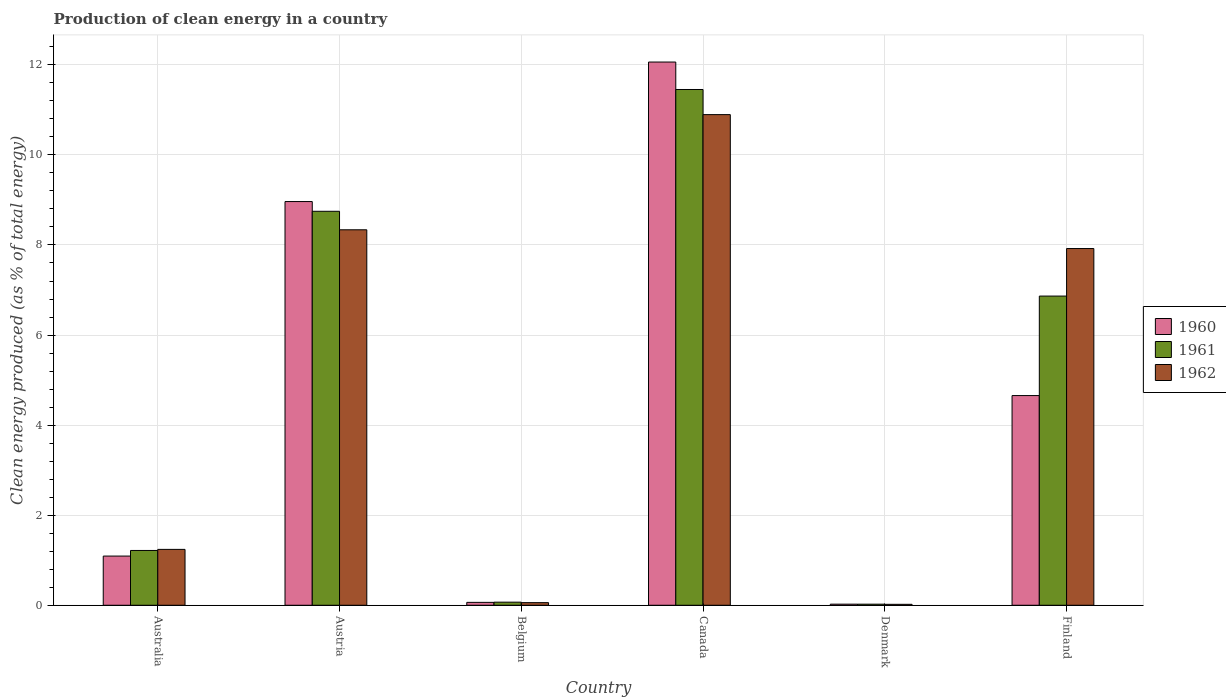How many different coloured bars are there?
Provide a succinct answer. 3. What is the percentage of clean energy produced in 1960 in Australia?
Give a very brief answer. 1.09. Across all countries, what is the maximum percentage of clean energy produced in 1960?
Ensure brevity in your answer.  12.06. Across all countries, what is the minimum percentage of clean energy produced in 1961?
Offer a terse response. 0.02. What is the total percentage of clean energy produced in 1961 in the graph?
Provide a short and direct response. 28.38. What is the difference between the percentage of clean energy produced in 1961 in Austria and that in Denmark?
Give a very brief answer. 8.72. What is the difference between the percentage of clean energy produced in 1960 in Belgium and the percentage of clean energy produced in 1961 in Canada?
Make the answer very short. -11.39. What is the average percentage of clean energy produced in 1960 per country?
Make the answer very short. 4.48. What is the difference between the percentage of clean energy produced of/in 1962 and percentage of clean energy produced of/in 1960 in Belgium?
Your answer should be compact. -0.01. What is the ratio of the percentage of clean energy produced in 1962 in Australia to that in Belgium?
Offer a very short reply. 21.34. What is the difference between the highest and the second highest percentage of clean energy produced in 1962?
Keep it short and to the point. -2.56. What is the difference between the highest and the lowest percentage of clean energy produced in 1960?
Offer a very short reply. 12.04. In how many countries, is the percentage of clean energy produced in 1961 greater than the average percentage of clean energy produced in 1961 taken over all countries?
Provide a succinct answer. 3. Is the sum of the percentage of clean energy produced in 1961 in Australia and Austria greater than the maximum percentage of clean energy produced in 1960 across all countries?
Offer a very short reply. No. Is it the case that in every country, the sum of the percentage of clean energy produced in 1962 and percentage of clean energy produced in 1960 is greater than the percentage of clean energy produced in 1961?
Offer a very short reply. Yes. How many bars are there?
Your answer should be very brief. 18. Are all the bars in the graph horizontal?
Your response must be concise. No. What is the difference between two consecutive major ticks on the Y-axis?
Provide a short and direct response. 2. Are the values on the major ticks of Y-axis written in scientific E-notation?
Give a very brief answer. No. Where does the legend appear in the graph?
Keep it short and to the point. Center right. What is the title of the graph?
Provide a short and direct response. Production of clean energy in a country. Does "2005" appear as one of the legend labels in the graph?
Your response must be concise. No. What is the label or title of the X-axis?
Provide a succinct answer. Country. What is the label or title of the Y-axis?
Offer a terse response. Clean energy produced (as % of total energy). What is the Clean energy produced (as % of total energy) of 1960 in Australia?
Keep it short and to the point. 1.09. What is the Clean energy produced (as % of total energy) of 1961 in Australia?
Ensure brevity in your answer.  1.22. What is the Clean energy produced (as % of total energy) in 1962 in Australia?
Your response must be concise. 1.24. What is the Clean energy produced (as % of total energy) in 1960 in Austria?
Keep it short and to the point. 8.96. What is the Clean energy produced (as % of total energy) of 1961 in Austria?
Make the answer very short. 8.75. What is the Clean energy produced (as % of total energy) of 1962 in Austria?
Provide a succinct answer. 8.34. What is the Clean energy produced (as % of total energy) in 1960 in Belgium?
Provide a short and direct response. 0.06. What is the Clean energy produced (as % of total energy) of 1961 in Belgium?
Offer a very short reply. 0.07. What is the Clean energy produced (as % of total energy) in 1962 in Belgium?
Keep it short and to the point. 0.06. What is the Clean energy produced (as % of total energy) in 1960 in Canada?
Provide a succinct answer. 12.06. What is the Clean energy produced (as % of total energy) in 1961 in Canada?
Give a very brief answer. 11.45. What is the Clean energy produced (as % of total energy) in 1962 in Canada?
Make the answer very short. 10.89. What is the Clean energy produced (as % of total energy) of 1960 in Denmark?
Provide a short and direct response. 0.02. What is the Clean energy produced (as % of total energy) of 1961 in Denmark?
Offer a very short reply. 0.02. What is the Clean energy produced (as % of total energy) of 1962 in Denmark?
Make the answer very short. 0.02. What is the Clean energy produced (as % of total energy) in 1960 in Finland?
Offer a terse response. 4.66. What is the Clean energy produced (as % of total energy) in 1961 in Finland?
Provide a succinct answer. 6.87. What is the Clean energy produced (as % of total energy) of 1962 in Finland?
Offer a very short reply. 7.92. Across all countries, what is the maximum Clean energy produced (as % of total energy) of 1960?
Make the answer very short. 12.06. Across all countries, what is the maximum Clean energy produced (as % of total energy) in 1961?
Offer a very short reply. 11.45. Across all countries, what is the maximum Clean energy produced (as % of total energy) in 1962?
Your answer should be very brief. 10.89. Across all countries, what is the minimum Clean energy produced (as % of total energy) of 1960?
Your answer should be very brief. 0.02. Across all countries, what is the minimum Clean energy produced (as % of total energy) of 1961?
Offer a terse response. 0.02. Across all countries, what is the minimum Clean energy produced (as % of total energy) in 1962?
Give a very brief answer. 0.02. What is the total Clean energy produced (as % of total energy) in 1960 in the graph?
Offer a terse response. 26.86. What is the total Clean energy produced (as % of total energy) in 1961 in the graph?
Give a very brief answer. 28.38. What is the total Clean energy produced (as % of total energy) in 1962 in the graph?
Make the answer very short. 28.47. What is the difference between the Clean energy produced (as % of total energy) of 1960 in Australia and that in Austria?
Your response must be concise. -7.87. What is the difference between the Clean energy produced (as % of total energy) in 1961 in Australia and that in Austria?
Ensure brevity in your answer.  -7.53. What is the difference between the Clean energy produced (as % of total energy) in 1962 in Australia and that in Austria?
Provide a succinct answer. -7.1. What is the difference between the Clean energy produced (as % of total energy) in 1960 in Australia and that in Belgium?
Provide a succinct answer. 1.03. What is the difference between the Clean energy produced (as % of total energy) of 1961 in Australia and that in Belgium?
Offer a very short reply. 1.15. What is the difference between the Clean energy produced (as % of total energy) in 1962 in Australia and that in Belgium?
Ensure brevity in your answer.  1.18. What is the difference between the Clean energy produced (as % of total energy) in 1960 in Australia and that in Canada?
Offer a terse response. -10.97. What is the difference between the Clean energy produced (as % of total energy) in 1961 in Australia and that in Canada?
Give a very brief answer. -10.24. What is the difference between the Clean energy produced (as % of total energy) in 1962 in Australia and that in Canada?
Your answer should be compact. -9.65. What is the difference between the Clean energy produced (as % of total energy) in 1960 in Australia and that in Denmark?
Your response must be concise. 1.07. What is the difference between the Clean energy produced (as % of total energy) in 1961 in Australia and that in Denmark?
Your response must be concise. 1.19. What is the difference between the Clean energy produced (as % of total energy) of 1962 in Australia and that in Denmark?
Ensure brevity in your answer.  1.22. What is the difference between the Clean energy produced (as % of total energy) in 1960 in Australia and that in Finland?
Make the answer very short. -3.56. What is the difference between the Clean energy produced (as % of total energy) of 1961 in Australia and that in Finland?
Keep it short and to the point. -5.65. What is the difference between the Clean energy produced (as % of total energy) of 1962 in Australia and that in Finland?
Ensure brevity in your answer.  -6.68. What is the difference between the Clean energy produced (as % of total energy) in 1960 in Austria and that in Belgium?
Offer a very short reply. 8.9. What is the difference between the Clean energy produced (as % of total energy) of 1961 in Austria and that in Belgium?
Provide a succinct answer. 8.68. What is the difference between the Clean energy produced (as % of total energy) in 1962 in Austria and that in Belgium?
Offer a terse response. 8.28. What is the difference between the Clean energy produced (as % of total energy) of 1960 in Austria and that in Canada?
Offer a very short reply. -3.1. What is the difference between the Clean energy produced (as % of total energy) in 1961 in Austria and that in Canada?
Your answer should be very brief. -2.7. What is the difference between the Clean energy produced (as % of total energy) of 1962 in Austria and that in Canada?
Provide a short and direct response. -2.56. What is the difference between the Clean energy produced (as % of total energy) of 1960 in Austria and that in Denmark?
Your response must be concise. 8.94. What is the difference between the Clean energy produced (as % of total energy) in 1961 in Austria and that in Denmark?
Your answer should be very brief. 8.72. What is the difference between the Clean energy produced (as % of total energy) in 1962 in Austria and that in Denmark?
Your response must be concise. 8.32. What is the difference between the Clean energy produced (as % of total energy) in 1960 in Austria and that in Finland?
Offer a very short reply. 4.31. What is the difference between the Clean energy produced (as % of total energy) of 1961 in Austria and that in Finland?
Provide a short and direct response. 1.88. What is the difference between the Clean energy produced (as % of total energy) in 1962 in Austria and that in Finland?
Make the answer very short. 0.42. What is the difference between the Clean energy produced (as % of total energy) in 1960 in Belgium and that in Canada?
Make the answer very short. -12. What is the difference between the Clean energy produced (as % of total energy) in 1961 in Belgium and that in Canada?
Ensure brevity in your answer.  -11.38. What is the difference between the Clean energy produced (as % of total energy) of 1962 in Belgium and that in Canada?
Your response must be concise. -10.84. What is the difference between the Clean energy produced (as % of total energy) in 1960 in Belgium and that in Denmark?
Your response must be concise. 0.04. What is the difference between the Clean energy produced (as % of total energy) in 1961 in Belgium and that in Denmark?
Your answer should be very brief. 0.04. What is the difference between the Clean energy produced (as % of total energy) of 1962 in Belgium and that in Denmark?
Your response must be concise. 0.04. What is the difference between the Clean energy produced (as % of total energy) in 1960 in Belgium and that in Finland?
Offer a terse response. -4.59. What is the difference between the Clean energy produced (as % of total energy) of 1961 in Belgium and that in Finland?
Provide a short and direct response. -6.8. What is the difference between the Clean energy produced (as % of total energy) of 1962 in Belgium and that in Finland?
Give a very brief answer. -7.86. What is the difference between the Clean energy produced (as % of total energy) of 1960 in Canada and that in Denmark?
Your answer should be compact. 12.04. What is the difference between the Clean energy produced (as % of total energy) in 1961 in Canada and that in Denmark?
Your answer should be very brief. 11.43. What is the difference between the Clean energy produced (as % of total energy) of 1962 in Canada and that in Denmark?
Ensure brevity in your answer.  10.87. What is the difference between the Clean energy produced (as % of total energy) in 1960 in Canada and that in Finland?
Make the answer very short. 7.41. What is the difference between the Clean energy produced (as % of total energy) of 1961 in Canada and that in Finland?
Ensure brevity in your answer.  4.59. What is the difference between the Clean energy produced (as % of total energy) of 1962 in Canada and that in Finland?
Your answer should be compact. 2.97. What is the difference between the Clean energy produced (as % of total energy) in 1960 in Denmark and that in Finland?
Offer a terse response. -4.63. What is the difference between the Clean energy produced (as % of total energy) of 1961 in Denmark and that in Finland?
Your answer should be compact. -6.84. What is the difference between the Clean energy produced (as % of total energy) in 1962 in Denmark and that in Finland?
Provide a succinct answer. -7.9. What is the difference between the Clean energy produced (as % of total energy) in 1960 in Australia and the Clean energy produced (as % of total energy) in 1961 in Austria?
Your answer should be very brief. -7.66. What is the difference between the Clean energy produced (as % of total energy) of 1960 in Australia and the Clean energy produced (as % of total energy) of 1962 in Austria?
Your response must be concise. -7.25. What is the difference between the Clean energy produced (as % of total energy) of 1961 in Australia and the Clean energy produced (as % of total energy) of 1962 in Austria?
Provide a succinct answer. -7.12. What is the difference between the Clean energy produced (as % of total energy) of 1960 in Australia and the Clean energy produced (as % of total energy) of 1961 in Belgium?
Offer a very short reply. 1.02. What is the difference between the Clean energy produced (as % of total energy) of 1960 in Australia and the Clean energy produced (as % of total energy) of 1962 in Belgium?
Provide a short and direct response. 1.03. What is the difference between the Clean energy produced (as % of total energy) in 1961 in Australia and the Clean energy produced (as % of total energy) in 1962 in Belgium?
Give a very brief answer. 1.16. What is the difference between the Clean energy produced (as % of total energy) in 1960 in Australia and the Clean energy produced (as % of total energy) in 1961 in Canada?
Make the answer very short. -10.36. What is the difference between the Clean energy produced (as % of total energy) of 1960 in Australia and the Clean energy produced (as % of total energy) of 1962 in Canada?
Provide a short and direct response. -9.8. What is the difference between the Clean energy produced (as % of total energy) of 1961 in Australia and the Clean energy produced (as % of total energy) of 1962 in Canada?
Ensure brevity in your answer.  -9.68. What is the difference between the Clean energy produced (as % of total energy) in 1960 in Australia and the Clean energy produced (as % of total energy) in 1961 in Denmark?
Ensure brevity in your answer.  1.07. What is the difference between the Clean energy produced (as % of total energy) of 1960 in Australia and the Clean energy produced (as % of total energy) of 1962 in Denmark?
Your response must be concise. 1.07. What is the difference between the Clean energy produced (as % of total energy) in 1961 in Australia and the Clean energy produced (as % of total energy) in 1962 in Denmark?
Offer a very short reply. 1.2. What is the difference between the Clean energy produced (as % of total energy) in 1960 in Australia and the Clean energy produced (as % of total energy) in 1961 in Finland?
Your response must be concise. -5.77. What is the difference between the Clean energy produced (as % of total energy) in 1960 in Australia and the Clean energy produced (as % of total energy) in 1962 in Finland?
Ensure brevity in your answer.  -6.83. What is the difference between the Clean energy produced (as % of total energy) of 1961 in Australia and the Clean energy produced (as % of total energy) of 1962 in Finland?
Keep it short and to the point. -6.7. What is the difference between the Clean energy produced (as % of total energy) in 1960 in Austria and the Clean energy produced (as % of total energy) in 1961 in Belgium?
Your answer should be very brief. 8.9. What is the difference between the Clean energy produced (as % of total energy) of 1960 in Austria and the Clean energy produced (as % of total energy) of 1962 in Belgium?
Offer a terse response. 8.91. What is the difference between the Clean energy produced (as % of total energy) of 1961 in Austria and the Clean energy produced (as % of total energy) of 1962 in Belgium?
Provide a short and direct response. 8.69. What is the difference between the Clean energy produced (as % of total energy) of 1960 in Austria and the Clean energy produced (as % of total energy) of 1961 in Canada?
Keep it short and to the point. -2.49. What is the difference between the Clean energy produced (as % of total energy) in 1960 in Austria and the Clean energy produced (as % of total energy) in 1962 in Canada?
Give a very brief answer. -1.93. What is the difference between the Clean energy produced (as % of total energy) of 1961 in Austria and the Clean energy produced (as % of total energy) of 1962 in Canada?
Ensure brevity in your answer.  -2.15. What is the difference between the Clean energy produced (as % of total energy) in 1960 in Austria and the Clean energy produced (as % of total energy) in 1961 in Denmark?
Your answer should be very brief. 8.94. What is the difference between the Clean energy produced (as % of total energy) of 1960 in Austria and the Clean energy produced (as % of total energy) of 1962 in Denmark?
Your answer should be very brief. 8.94. What is the difference between the Clean energy produced (as % of total energy) in 1961 in Austria and the Clean energy produced (as % of total energy) in 1962 in Denmark?
Keep it short and to the point. 8.73. What is the difference between the Clean energy produced (as % of total energy) in 1960 in Austria and the Clean energy produced (as % of total energy) in 1961 in Finland?
Your response must be concise. 2.1. What is the difference between the Clean energy produced (as % of total energy) of 1960 in Austria and the Clean energy produced (as % of total energy) of 1962 in Finland?
Your answer should be very brief. 1.04. What is the difference between the Clean energy produced (as % of total energy) in 1961 in Austria and the Clean energy produced (as % of total energy) in 1962 in Finland?
Ensure brevity in your answer.  0.83. What is the difference between the Clean energy produced (as % of total energy) of 1960 in Belgium and the Clean energy produced (as % of total energy) of 1961 in Canada?
Your answer should be compact. -11.39. What is the difference between the Clean energy produced (as % of total energy) of 1960 in Belgium and the Clean energy produced (as % of total energy) of 1962 in Canada?
Make the answer very short. -10.83. What is the difference between the Clean energy produced (as % of total energy) of 1961 in Belgium and the Clean energy produced (as % of total energy) of 1962 in Canada?
Offer a terse response. -10.83. What is the difference between the Clean energy produced (as % of total energy) in 1960 in Belgium and the Clean energy produced (as % of total energy) in 1961 in Denmark?
Your answer should be very brief. 0.04. What is the difference between the Clean energy produced (as % of total energy) of 1960 in Belgium and the Clean energy produced (as % of total energy) of 1962 in Denmark?
Offer a very short reply. 0.04. What is the difference between the Clean energy produced (as % of total energy) in 1961 in Belgium and the Clean energy produced (as % of total energy) in 1962 in Denmark?
Your answer should be compact. 0.05. What is the difference between the Clean energy produced (as % of total energy) in 1960 in Belgium and the Clean energy produced (as % of total energy) in 1961 in Finland?
Your answer should be very brief. -6.8. What is the difference between the Clean energy produced (as % of total energy) in 1960 in Belgium and the Clean energy produced (as % of total energy) in 1962 in Finland?
Ensure brevity in your answer.  -7.86. What is the difference between the Clean energy produced (as % of total energy) of 1961 in Belgium and the Clean energy produced (as % of total energy) of 1962 in Finland?
Keep it short and to the point. -7.85. What is the difference between the Clean energy produced (as % of total energy) in 1960 in Canada and the Clean energy produced (as % of total energy) in 1961 in Denmark?
Offer a terse response. 12.04. What is the difference between the Clean energy produced (as % of total energy) of 1960 in Canada and the Clean energy produced (as % of total energy) of 1962 in Denmark?
Your response must be concise. 12.04. What is the difference between the Clean energy produced (as % of total energy) in 1961 in Canada and the Clean energy produced (as % of total energy) in 1962 in Denmark?
Offer a terse response. 11.43. What is the difference between the Clean energy produced (as % of total energy) in 1960 in Canada and the Clean energy produced (as % of total energy) in 1961 in Finland?
Provide a short and direct response. 5.2. What is the difference between the Clean energy produced (as % of total energy) of 1960 in Canada and the Clean energy produced (as % of total energy) of 1962 in Finland?
Provide a succinct answer. 4.14. What is the difference between the Clean energy produced (as % of total energy) in 1961 in Canada and the Clean energy produced (as % of total energy) in 1962 in Finland?
Offer a terse response. 3.53. What is the difference between the Clean energy produced (as % of total energy) in 1960 in Denmark and the Clean energy produced (as % of total energy) in 1961 in Finland?
Your response must be concise. -6.84. What is the difference between the Clean energy produced (as % of total energy) in 1960 in Denmark and the Clean energy produced (as % of total energy) in 1962 in Finland?
Your answer should be very brief. -7.9. What is the difference between the Clean energy produced (as % of total energy) in 1961 in Denmark and the Clean energy produced (as % of total energy) in 1962 in Finland?
Ensure brevity in your answer.  -7.9. What is the average Clean energy produced (as % of total energy) in 1960 per country?
Offer a very short reply. 4.48. What is the average Clean energy produced (as % of total energy) in 1961 per country?
Offer a very short reply. 4.73. What is the average Clean energy produced (as % of total energy) in 1962 per country?
Your answer should be very brief. 4.75. What is the difference between the Clean energy produced (as % of total energy) in 1960 and Clean energy produced (as % of total energy) in 1961 in Australia?
Make the answer very short. -0.12. What is the difference between the Clean energy produced (as % of total energy) of 1960 and Clean energy produced (as % of total energy) of 1962 in Australia?
Provide a succinct answer. -0.15. What is the difference between the Clean energy produced (as % of total energy) in 1961 and Clean energy produced (as % of total energy) in 1962 in Australia?
Keep it short and to the point. -0.02. What is the difference between the Clean energy produced (as % of total energy) in 1960 and Clean energy produced (as % of total energy) in 1961 in Austria?
Your answer should be very brief. 0.22. What is the difference between the Clean energy produced (as % of total energy) in 1960 and Clean energy produced (as % of total energy) in 1962 in Austria?
Make the answer very short. 0.63. What is the difference between the Clean energy produced (as % of total energy) of 1961 and Clean energy produced (as % of total energy) of 1962 in Austria?
Make the answer very short. 0.41. What is the difference between the Clean energy produced (as % of total energy) in 1960 and Clean energy produced (as % of total energy) in 1961 in Belgium?
Ensure brevity in your answer.  -0. What is the difference between the Clean energy produced (as % of total energy) of 1960 and Clean energy produced (as % of total energy) of 1962 in Belgium?
Provide a succinct answer. 0.01. What is the difference between the Clean energy produced (as % of total energy) of 1961 and Clean energy produced (as % of total energy) of 1962 in Belgium?
Your answer should be very brief. 0.01. What is the difference between the Clean energy produced (as % of total energy) in 1960 and Clean energy produced (as % of total energy) in 1961 in Canada?
Make the answer very short. 0.61. What is the difference between the Clean energy produced (as % of total energy) of 1960 and Clean energy produced (as % of total energy) of 1962 in Canada?
Your answer should be compact. 1.17. What is the difference between the Clean energy produced (as % of total energy) of 1961 and Clean energy produced (as % of total energy) of 1962 in Canada?
Your answer should be very brief. 0.56. What is the difference between the Clean energy produced (as % of total energy) in 1960 and Clean energy produced (as % of total energy) in 1962 in Denmark?
Provide a succinct answer. 0. What is the difference between the Clean energy produced (as % of total energy) of 1961 and Clean energy produced (as % of total energy) of 1962 in Denmark?
Your answer should be very brief. 0. What is the difference between the Clean energy produced (as % of total energy) of 1960 and Clean energy produced (as % of total energy) of 1961 in Finland?
Keep it short and to the point. -2.21. What is the difference between the Clean energy produced (as % of total energy) in 1960 and Clean energy produced (as % of total energy) in 1962 in Finland?
Ensure brevity in your answer.  -3.26. What is the difference between the Clean energy produced (as % of total energy) in 1961 and Clean energy produced (as % of total energy) in 1962 in Finland?
Offer a terse response. -1.06. What is the ratio of the Clean energy produced (as % of total energy) in 1960 in Australia to that in Austria?
Ensure brevity in your answer.  0.12. What is the ratio of the Clean energy produced (as % of total energy) in 1961 in Australia to that in Austria?
Keep it short and to the point. 0.14. What is the ratio of the Clean energy produced (as % of total energy) of 1962 in Australia to that in Austria?
Make the answer very short. 0.15. What is the ratio of the Clean energy produced (as % of total energy) in 1960 in Australia to that in Belgium?
Offer a terse response. 17.03. What is the ratio of the Clean energy produced (as % of total energy) of 1961 in Australia to that in Belgium?
Offer a terse response. 17.67. What is the ratio of the Clean energy produced (as % of total energy) in 1962 in Australia to that in Belgium?
Give a very brief answer. 21.34. What is the ratio of the Clean energy produced (as % of total energy) in 1960 in Australia to that in Canada?
Make the answer very short. 0.09. What is the ratio of the Clean energy produced (as % of total energy) in 1961 in Australia to that in Canada?
Ensure brevity in your answer.  0.11. What is the ratio of the Clean energy produced (as % of total energy) in 1962 in Australia to that in Canada?
Keep it short and to the point. 0.11. What is the ratio of the Clean energy produced (as % of total energy) of 1960 in Australia to that in Denmark?
Make the answer very short. 44.73. What is the ratio of the Clean energy produced (as % of total energy) in 1961 in Australia to that in Denmark?
Your answer should be compact. 50.77. What is the ratio of the Clean energy produced (as % of total energy) of 1962 in Australia to that in Denmark?
Make the answer very short. 59.22. What is the ratio of the Clean energy produced (as % of total energy) of 1960 in Australia to that in Finland?
Your answer should be compact. 0.23. What is the ratio of the Clean energy produced (as % of total energy) of 1961 in Australia to that in Finland?
Keep it short and to the point. 0.18. What is the ratio of the Clean energy produced (as % of total energy) in 1962 in Australia to that in Finland?
Ensure brevity in your answer.  0.16. What is the ratio of the Clean energy produced (as % of total energy) of 1960 in Austria to that in Belgium?
Keep it short and to the point. 139.76. What is the ratio of the Clean energy produced (as % of total energy) in 1961 in Austria to that in Belgium?
Your answer should be very brief. 127.07. What is the ratio of the Clean energy produced (as % of total energy) of 1962 in Austria to that in Belgium?
Offer a very short reply. 143.44. What is the ratio of the Clean energy produced (as % of total energy) of 1960 in Austria to that in Canada?
Offer a terse response. 0.74. What is the ratio of the Clean energy produced (as % of total energy) in 1961 in Austria to that in Canada?
Your answer should be very brief. 0.76. What is the ratio of the Clean energy produced (as % of total energy) of 1962 in Austria to that in Canada?
Your answer should be compact. 0.77. What is the ratio of the Clean energy produced (as % of total energy) of 1960 in Austria to that in Denmark?
Provide a short and direct response. 367.18. What is the ratio of the Clean energy produced (as % of total energy) of 1961 in Austria to that in Denmark?
Offer a terse response. 365.06. What is the ratio of the Clean energy produced (as % of total energy) in 1962 in Austria to that in Denmark?
Your answer should be very brief. 397.95. What is the ratio of the Clean energy produced (as % of total energy) of 1960 in Austria to that in Finland?
Your response must be concise. 1.93. What is the ratio of the Clean energy produced (as % of total energy) in 1961 in Austria to that in Finland?
Keep it short and to the point. 1.27. What is the ratio of the Clean energy produced (as % of total energy) in 1962 in Austria to that in Finland?
Your answer should be compact. 1.05. What is the ratio of the Clean energy produced (as % of total energy) of 1960 in Belgium to that in Canada?
Offer a very short reply. 0.01. What is the ratio of the Clean energy produced (as % of total energy) in 1961 in Belgium to that in Canada?
Give a very brief answer. 0.01. What is the ratio of the Clean energy produced (as % of total energy) in 1962 in Belgium to that in Canada?
Provide a succinct answer. 0.01. What is the ratio of the Clean energy produced (as % of total energy) in 1960 in Belgium to that in Denmark?
Your answer should be very brief. 2.63. What is the ratio of the Clean energy produced (as % of total energy) in 1961 in Belgium to that in Denmark?
Ensure brevity in your answer.  2.87. What is the ratio of the Clean energy produced (as % of total energy) of 1962 in Belgium to that in Denmark?
Provide a short and direct response. 2.77. What is the ratio of the Clean energy produced (as % of total energy) in 1960 in Belgium to that in Finland?
Offer a terse response. 0.01. What is the ratio of the Clean energy produced (as % of total energy) in 1961 in Belgium to that in Finland?
Your response must be concise. 0.01. What is the ratio of the Clean energy produced (as % of total energy) of 1962 in Belgium to that in Finland?
Offer a terse response. 0.01. What is the ratio of the Clean energy produced (as % of total energy) in 1960 in Canada to that in Denmark?
Offer a very short reply. 494.07. What is the ratio of the Clean energy produced (as % of total energy) of 1961 in Canada to that in Denmark?
Ensure brevity in your answer.  477.92. What is the ratio of the Clean energy produced (as % of total energy) of 1962 in Canada to that in Denmark?
Offer a terse response. 520.01. What is the ratio of the Clean energy produced (as % of total energy) of 1960 in Canada to that in Finland?
Keep it short and to the point. 2.59. What is the ratio of the Clean energy produced (as % of total energy) of 1961 in Canada to that in Finland?
Offer a very short reply. 1.67. What is the ratio of the Clean energy produced (as % of total energy) of 1962 in Canada to that in Finland?
Give a very brief answer. 1.38. What is the ratio of the Clean energy produced (as % of total energy) of 1960 in Denmark to that in Finland?
Ensure brevity in your answer.  0.01. What is the ratio of the Clean energy produced (as % of total energy) in 1961 in Denmark to that in Finland?
Offer a terse response. 0. What is the ratio of the Clean energy produced (as % of total energy) in 1962 in Denmark to that in Finland?
Ensure brevity in your answer.  0. What is the difference between the highest and the second highest Clean energy produced (as % of total energy) in 1960?
Give a very brief answer. 3.1. What is the difference between the highest and the second highest Clean energy produced (as % of total energy) in 1961?
Provide a short and direct response. 2.7. What is the difference between the highest and the second highest Clean energy produced (as % of total energy) in 1962?
Your response must be concise. 2.56. What is the difference between the highest and the lowest Clean energy produced (as % of total energy) of 1960?
Keep it short and to the point. 12.04. What is the difference between the highest and the lowest Clean energy produced (as % of total energy) of 1961?
Provide a short and direct response. 11.43. What is the difference between the highest and the lowest Clean energy produced (as % of total energy) in 1962?
Give a very brief answer. 10.87. 